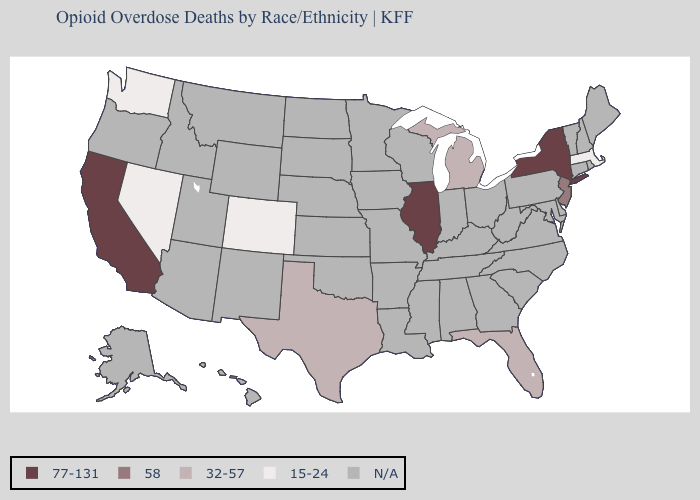Name the states that have a value in the range 58?
Keep it brief. New Jersey. What is the highest value in the USA?
Quick response, please. 77-131. What is the value of Pennsylvania?
Concise answer only. N/A. Name the states that have a value in the range 32-57?
Short answer required. Florida, Michigan, Texas. Name the states that have a value in the range N/A?
Answer briefly. Alabama, Alaska, Arizona, Arkansas, Connecticut, Delaware, Georgia, Hawaii, Idaho, Indiana, Iowa, Kansas, Kentucky, Louisiana, Maine, Maryland, Minnesota, Mississippi, Missouri, Montana, Nebraska, New Hampshire, New Mexico, North Carolina, North Dakota, Ohio, Oklahoma, Oregon, Pennsylvania, Rhode Island, South Carolina, South Dakota, Tennessee, Utah, Vermont, Virginia, West Virginia, Wisconsin, Wyoming. Which states have the lowest value in the USA?
Short answer required. Colorado, Massachusetts, Nevada, Washington. What is the highest value in the MidWest ?
Short answer required. 77-131. What is the lowest value in states that border Nebraska?
Concise answer only. 15-24. Name the states that have a value in the range 32-57?
Keep it brief. Florida, Michigan, Texas. What is the value of California?
Concise answer only. 77-131. Which states have the lowest value in the USA?
Answer briefly. Colorado, Massachusetts, Nevada, Washington. Name the states that have a value in the range 32-57?
Be succinct. Florida, Michigan, Texas. What is the value of Vermont?
Keep it brief. N/A. Name the states that have a value in the range 32-57?
Answer briefly. Florida, Michigan, Texas. 